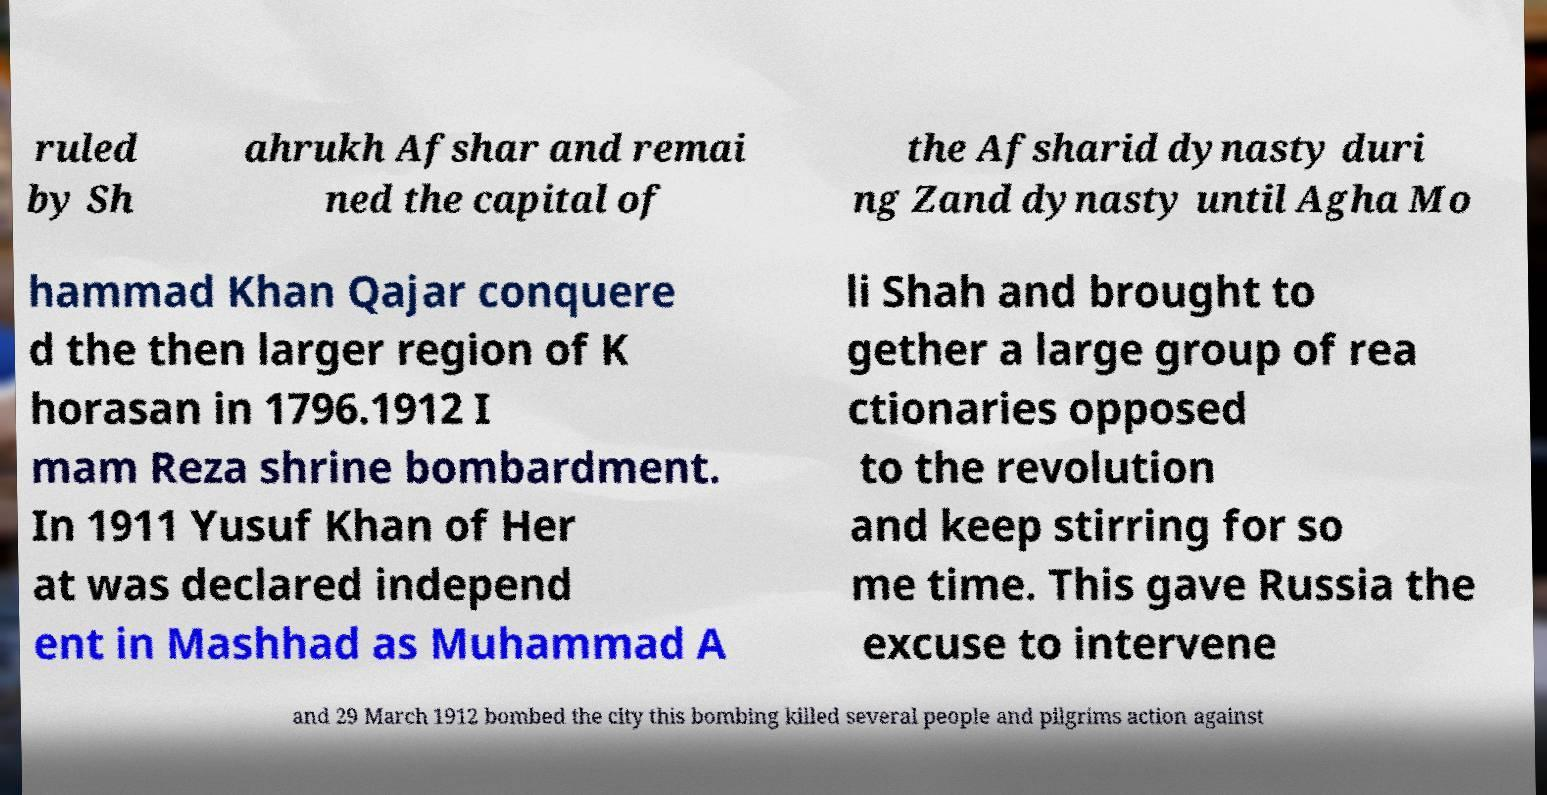Could you assist in decoding the text presented in this image and type it out clearly? ruled by Sh ahrukh Afshar and remai ned the capital of the Afsharid dynasty duri ng Zand dynasty until Agha Mo hammad Khan Qajar conquere d the then larger region of K horasan in 1796.1912 I mam Reza shrine bombardment. In 1911 Yusuf Khan of Her at was declared independ ent in Mashhad as Muhammad A li Shah and brought to gether a large group of rea ctionaries opposed to the revolution and keep stirring for so me time. This gave Russia the excuse to intervene and 29 March 1912 bombed the city this bombing killed several people and pilgrims action against 